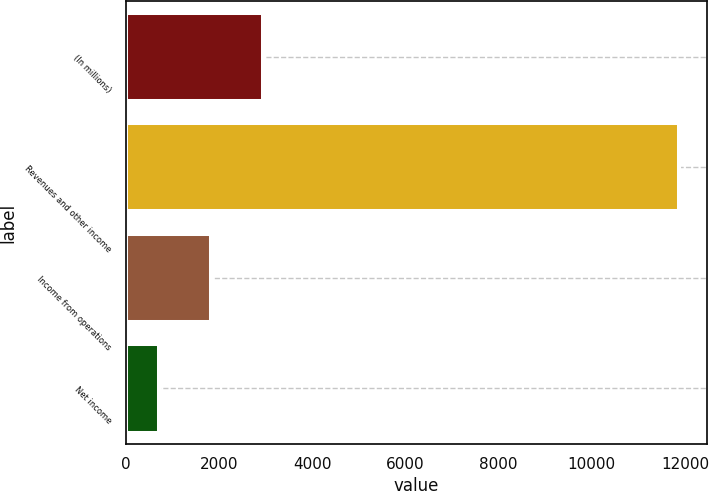<chart> <loc_0><loc_0><loc_500><loc_500><bar_chart><fcel>(In millions)<fcel>Revenues and other income<fcel>Income from operations<fcel>Net income<nl><fcel>2942.6<fcel>11873<fcel>1826.3<fcel>710<nl></chart> 